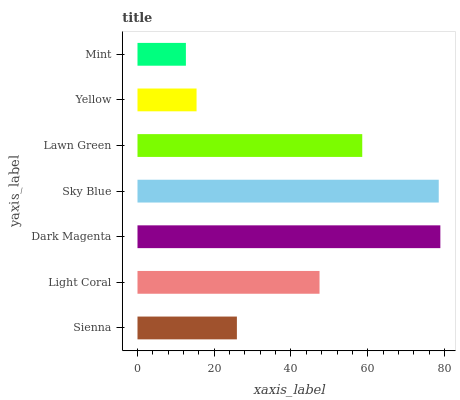Is Mint the minimum?
Answer yes or no. Yes. Is Dark Magenta the maximum?
Answer yes or no. Yes. Is Light Coral the minimum?
Answer yes or no. No. Is Light Coral the maximum?
Answer yes or no. No. Is Light Coral greater than Sienna?
Answer yes or no. Yes. Is Sienna less than Light Coral?
Answer yes or no. Yes. Is Sienna greater than Light Coral?
Answer yes or no. No. Is Light Coral less than Sienna?
Answer yes or no. No. Is Light Coral the high median?
Answer yes or no. Yes. Is Light Coral the low median?
Answer yes or no. Yes. Is Dark Magenta the high median?
Answer yes or no. No. Is Yellow the low median?
Answer yes or no. No. 